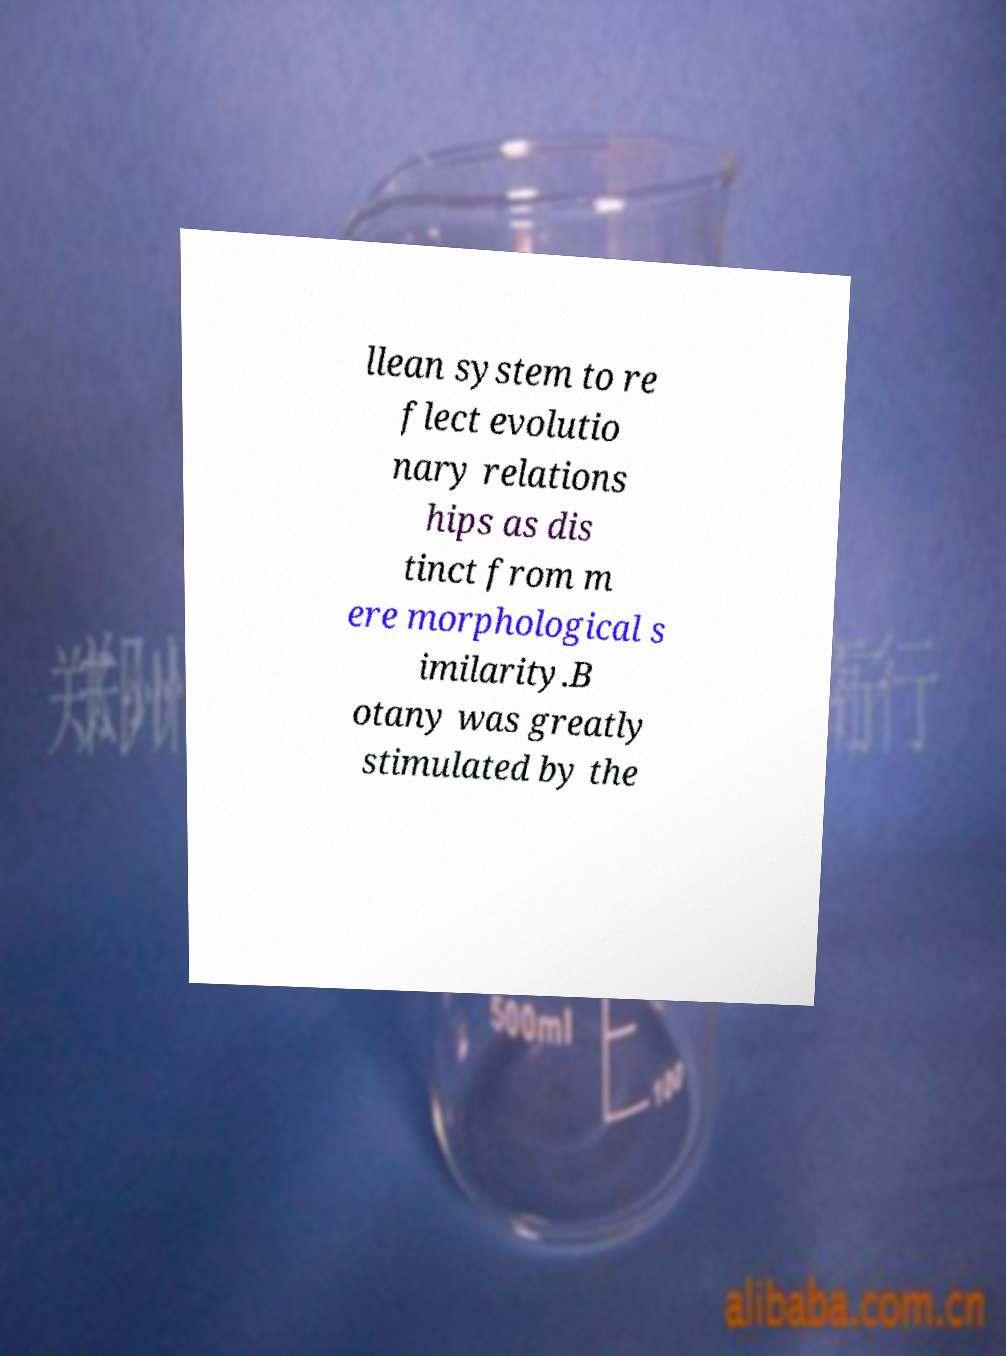There's text embedded in this image that I need extracted. Can you transcribe it verbatim? llean system to re flect evolutio nary relations hips as dis tinct from m ere morphological s imilarity.B otany was greatly stimulated by the 